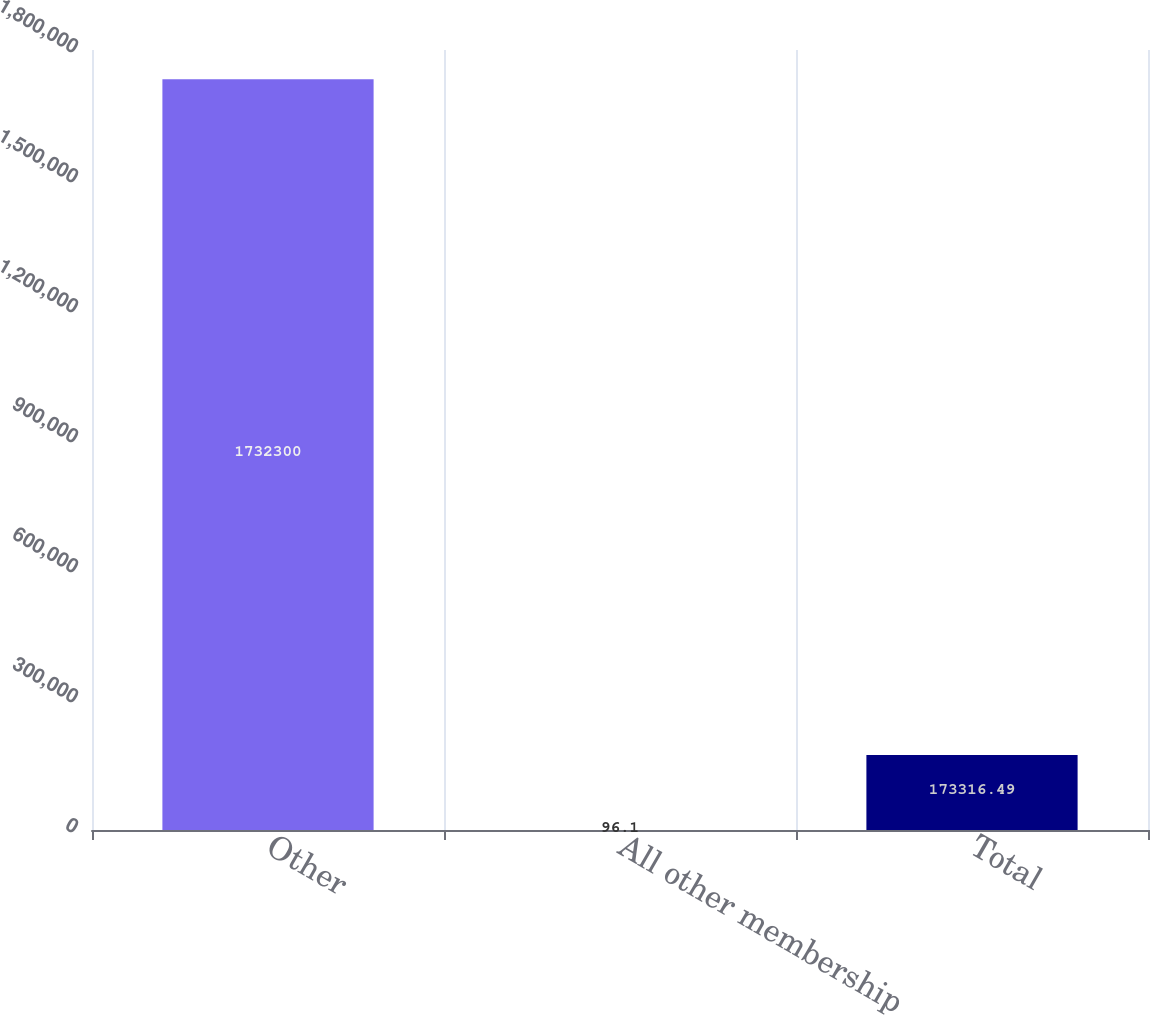Convert chart to OTSL. <chart><loc_0><loc_0><loc_500><loc_500><bar_chart><fcel>Other<fcel>All other membership<fcel>Total<nl><fcel>1.7323e+06<fcel>96.1<fcel>173316<nl></chart> 